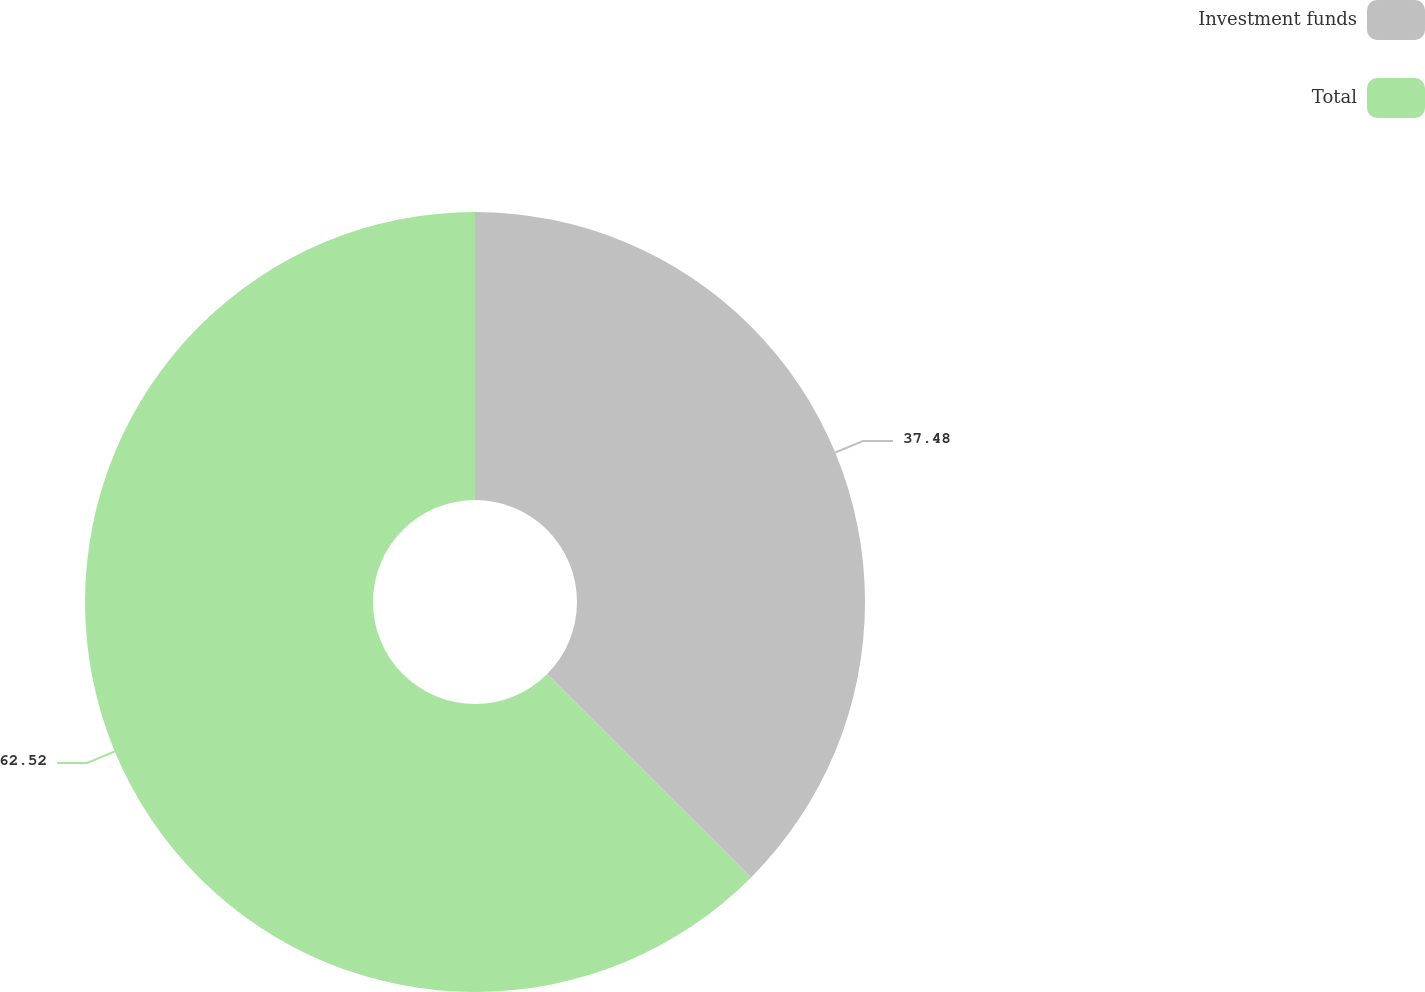Convert chart. <chart><loc_0><loc_0><loc_500><loc_500><pie_chart><fcel>Investment funds<fcel>Total<nl><fcel>37.48%<fcel>62.52%<nl></chart> 